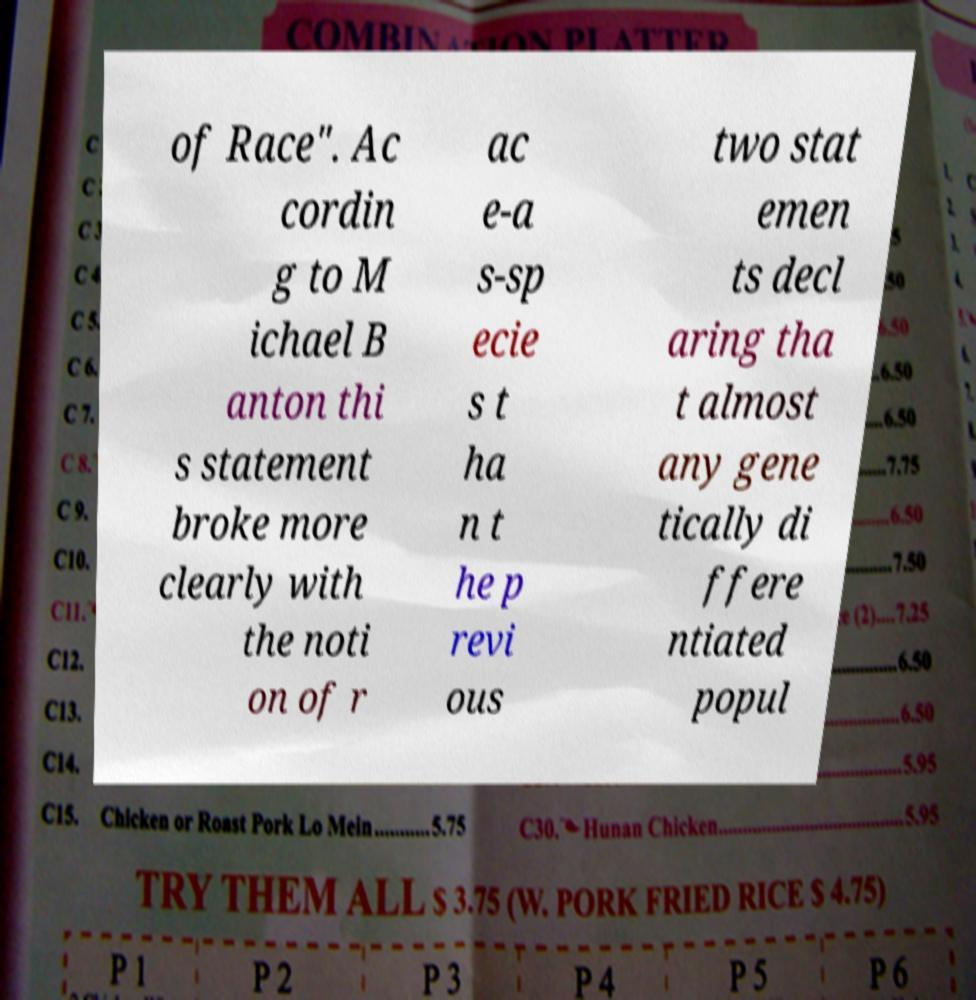What messages or text are displayed in this image? I need them in a readable, typed format. of Race". Ac cordin g to M ichael B anton thi s statement broke more clearly with the noti on of r ac e-a s-sp ecie s t ha n t he p revi ous two stat emen ts decl aring tha t almost any gene tically di ffere ntiated popul 